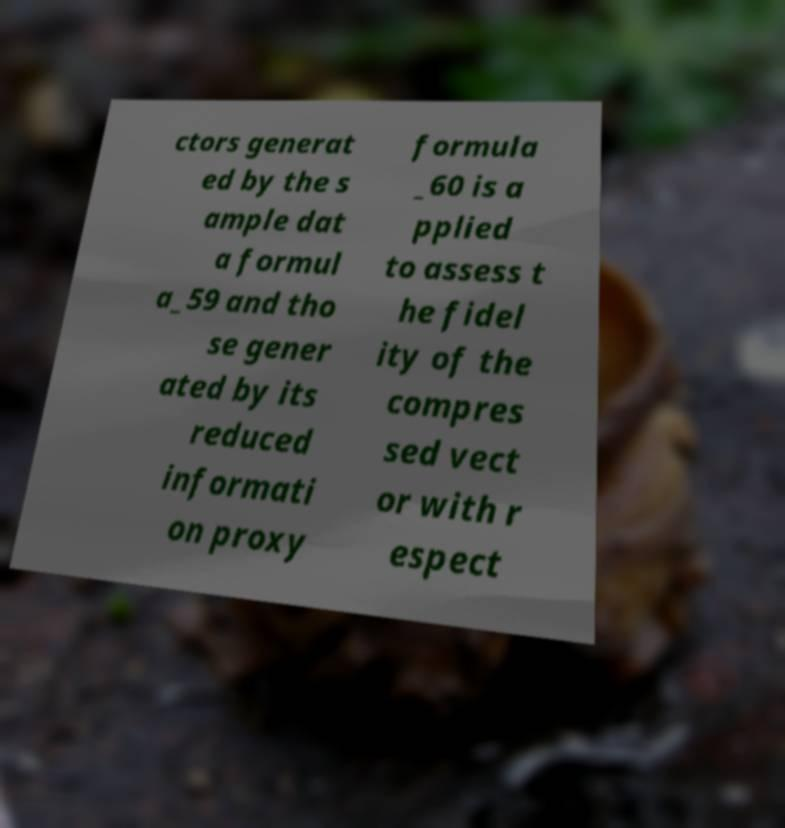Please identify and transcribe the text found in this image. ctors generat ed by the s ample dat a formul a_59 and tho se gener ated by its reduced informati on proxy formula _60 is a pplied to assess t he fidel ity of the compres sed vect or with r espect 